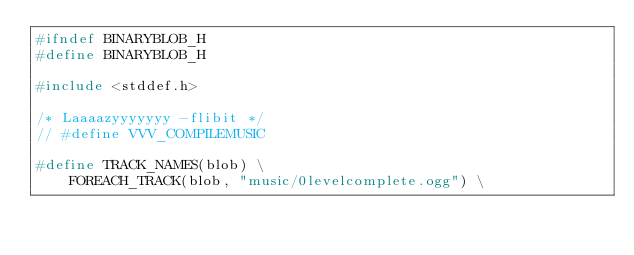Convert code to text. <code><loc_0><loc_0><loc_500><loc_500><_C_>#ifndef BINARYBLOB_H
#define BINARYBLOB_H

#include <stddef.h>

/* Laaaazyyyyyyy -flibit */
// #define VVV_COMPILEMUSIC

#define TRACK_NAMES(blob) \
	FOREACH_TRACK(blob, "music/0levelcomplete.ogg") \</code> 